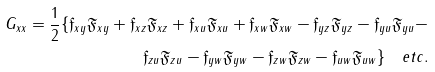<formula> <loc_0><loc_0><loc_500><loc_500>G _ { x x } = \frac { 1 } { 2 } \{ \mathfrak { f } _ { x y } \mathfrak { F } _ { x y } + \mathfrak { f } _ { x z } \mathfrak { F } _ { x z } + \mathfrak { f } _ { x u } \mathfrak { F } _ { x u } + \mathfrak { f } _ { x w } \mathfrak { F } _ { x w } - \mathfrak { f } _ { y z } \mathfrak { F } _ { y z } - \mathfrak { f } _ { y u } \mathfrak { F } _ { y u } - \\ \mathfrak { f } _ { z u } \mathfrak { F } _ { z u } - \mathfrak { f } _ { y w } \mathfrak { F } _ { y w } - \mathfrak { f } _ { z w } \mathfrak { F } _ { z w } - \mathfrak { f } _ { u w } \mathfrak { F } _ { u w } \} \quad e t c .</formula> 